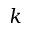<formula> <loc_0><loc_0><loc_500><loc_500>k</formula> 